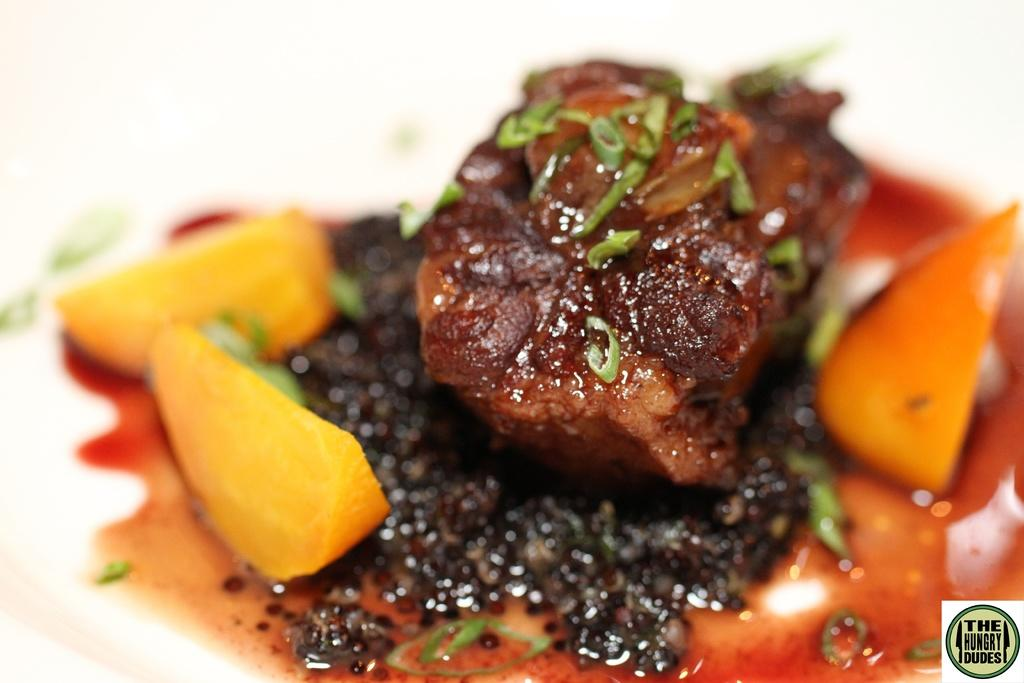What types of food items are present in the image? The image contains food items. What colors can be observed in the food items? The food items have brown, orange, and yellow colors. Are there any other colors present on the food items? Yes, there are green color things on the food items. Can you tell me the name of the person who ordered the food in the image? There is no person present in the image, and therefore no one to have ordered the food. 